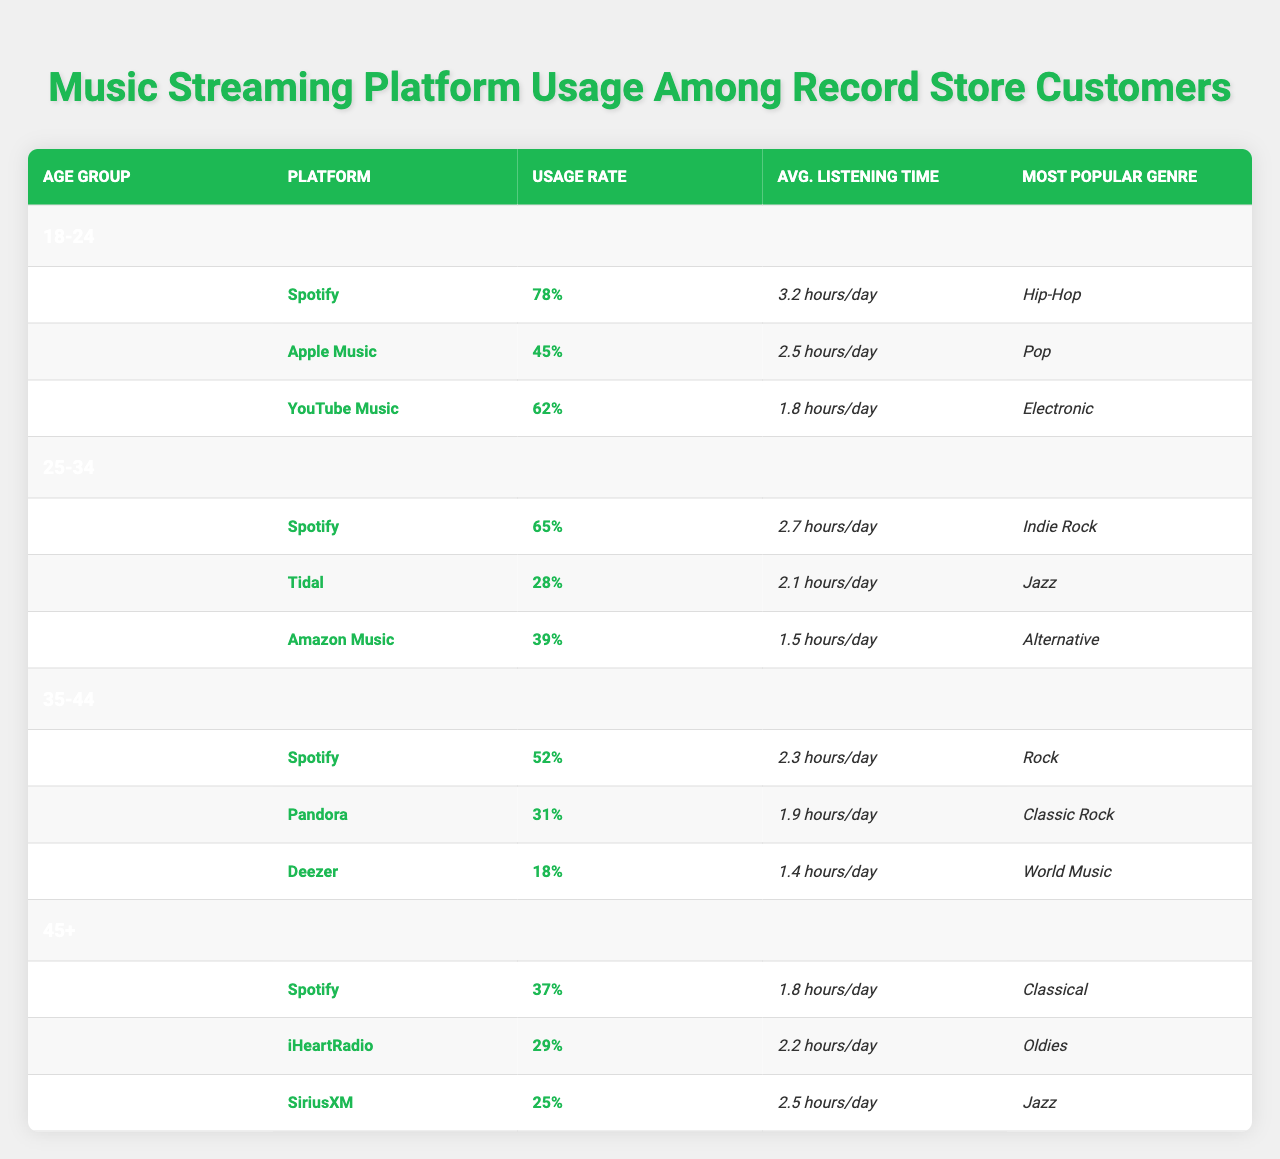What is the most popular genre among 18-24 year olds using Spotify? The table indicates that the most popular genre for Spotify users in the 18-24 age group is Hip-Hop.
Answer: Hip-Hop Which platform has the highest usage rate among 25-34 year olds? In the 25-34 age group, Spotify has the highest usage rate at 65%.
Answer: Spotify What is the average listening time for users aged 35-44 on Pandora? For the 35-44 age group, the average listening time on Pandora is 1.9 hours per day, as directly referenced in the table.
Answer: 1.9 hours/day Is the average listening time on Apple Music greater than that of Amazon Music for 25-34 year olds? The average listening time for Apple Music is 2.5 hours per day while for Amazon Music it is 1.5 hours per day. Since 2.5 is greater than 1.5, the statement is true.
Answer: Yes How much higher is the usage rate of Spotify for ages 18-24 compared to ages 45 and older? The usage rate of Spotify among 18-24 year olds is 78%, while for those aged 45 and older it is 37%. The difference is 78% - 37% = 41%.
Answer: 41% What percentage of users aged 45+ use iHeartRadio? The table shows that 29% of users aged 45 and older use iHeartRadio directly from the data.
Answer: 29% Which genre is the most popular among 35-44 year olds on Deezer? According to the table, the most popular genre among 35-44 year olds using Deezer is World Music.
Answer: World Music Based on the average listening times, which age group spends the most time listening to music on Apple Music? Among the age groups, users aged 18-24 have the highest average listening time on Apple Music at 2.5 hours/day.
Answer: 18-24 How do the usage rates of Tidal and Deezer compare for users aged 35-44? The usage rate for Tidal is 31% and for Deezer it is 18%. Thus, Tidal has a higher usage rate than Deezer by 13%.
Answer: Tidal is higher by 13% Which age group shows the least usage for Spotify? Among the listed age groups, the 45+ age group shows the least usage for Spotify at 37%.
Answer: 45+ 